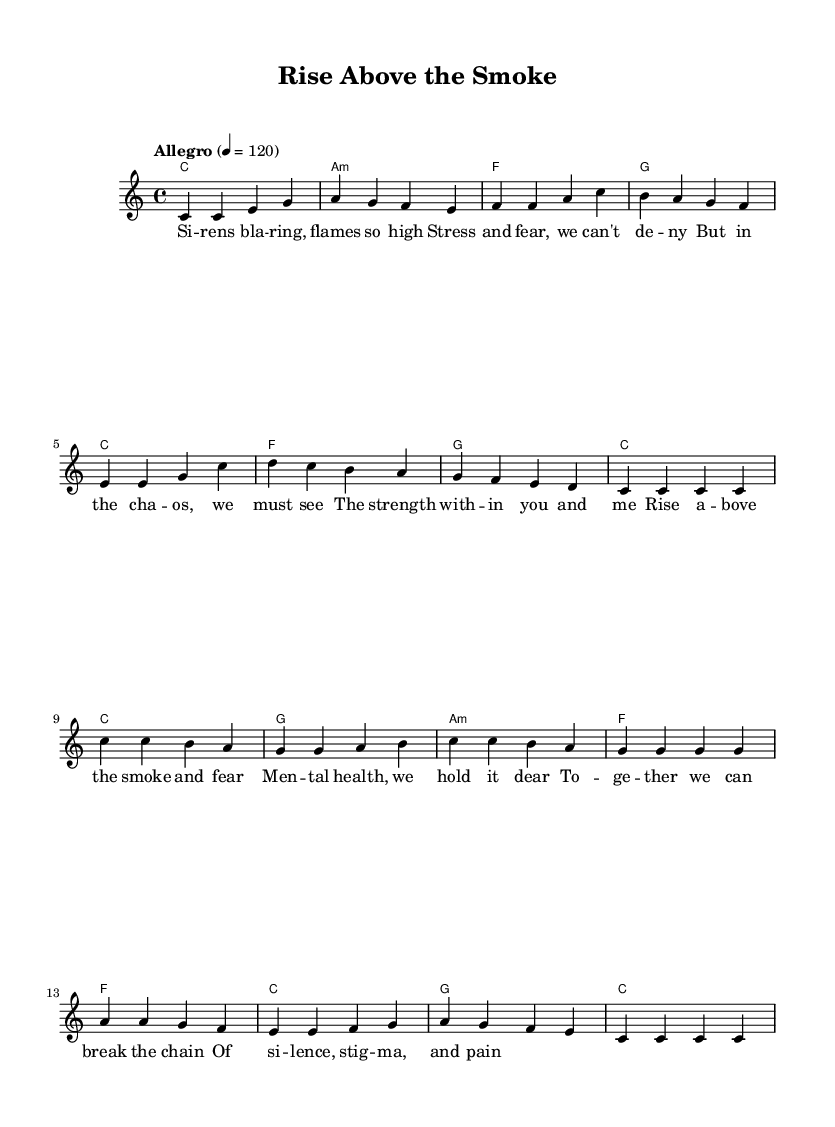What is the key signature of this music? The key signature is indicated at the beginning of the sheet music and shows no sharps or flats, which corresponds to C major.
Answer: C major What is the time signature of this music? The time signature is found in the beginning section of the sheet music, which shows a 4 over 4 representation, indicating four beats per measure.
Answer: 4/4 What is the tempo marking of the piece? The tempo marking is typically written at the beginning of the score, and here it states "Allegro" with a metronome marking of 120 beats per minute.
Answer: 120 How many measures are in the verse section? By counting each distinct group of notes separated by the bar lines for the verse, you can determine the total number of measures. There are eight measures in the verse section.
Answer: Eight What is the first lyric line of the chorus? The first line can be identified by looking under the melody notes in the chorus section, where it reads "Rise above the smoke and fear."
Answer: Rise above the smoke and fear What is the chord progression used in the chorus? Analyzing the chord names above the melody for the chorus reveals the sequence of chords used; in this piece, the progression is C, G, A minor, F.
Answer: C, G, A minor, F How does the melody for the chorus begin? The melody for the chorus can be identified by looking at the notes in the melody staff that correspond to the lyrics. It starts with a C note on the first beat of the chorus.
Answer: C 